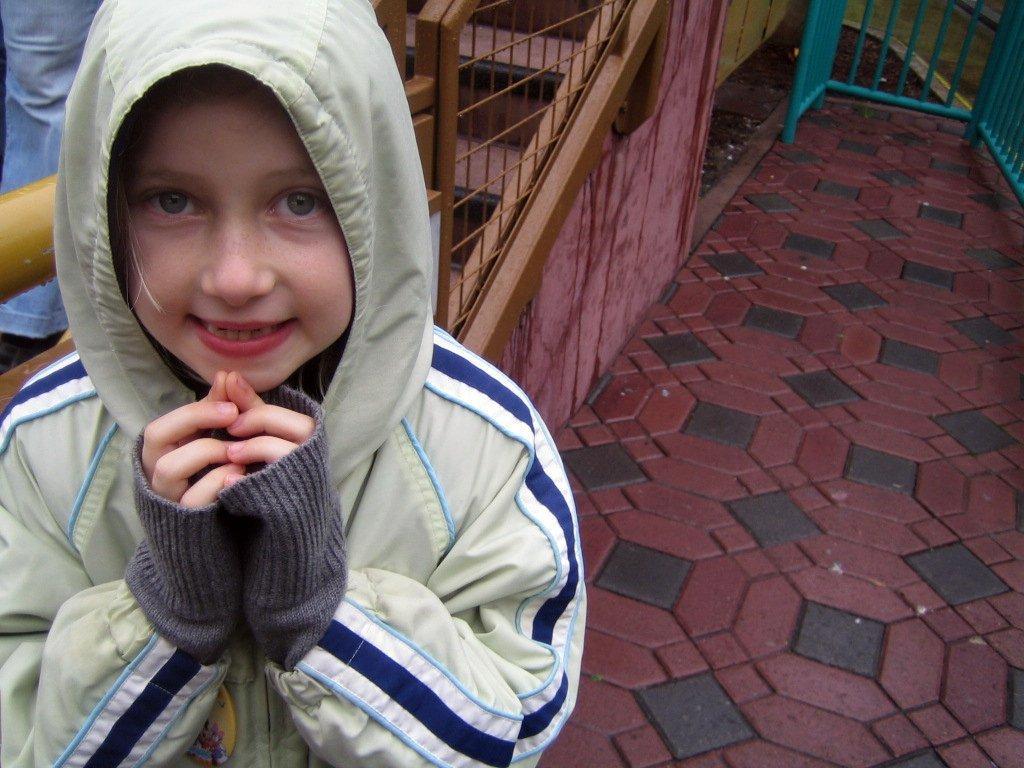Can you describe this image briefly? It is image in the front there is a boy standing and having some expression on his face. In the background there is a staircase and there is a fence. On the left side there is an object which is blue in colour. 